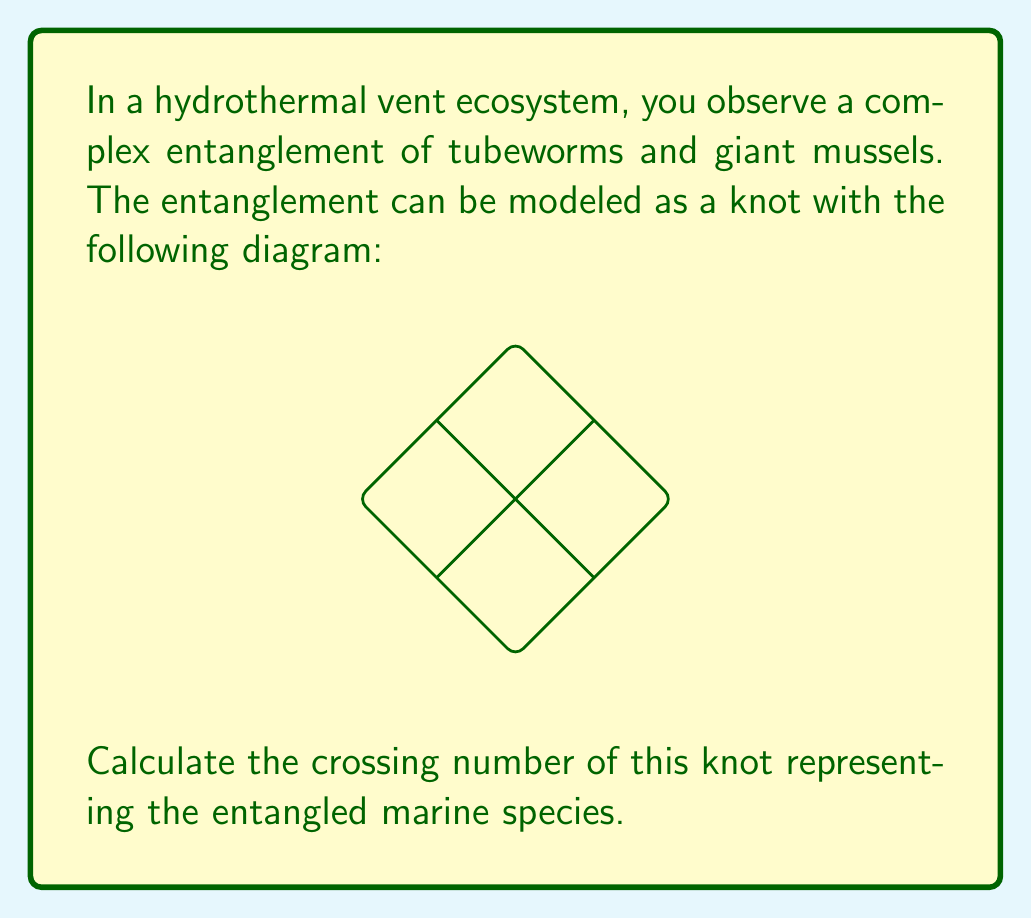What is the answer to this math problem? To determine the crossing number of the knot representing the entangled marine species, we need to follow these steps:

1. Understand the definition: The crossing number of a knot is the minimum number of crossings that occur in any projection of the knot onto a plane.

2. Analyze the given diagram:
   - Count the number of crossings in the provided projection.
   - In this diagram, we can clearly see 4 crossings.

3. Consider if this is the minimal representation:
   - For this particular knot, known as the "figure-eight knot," it is proven that 4 is indeed the minimal number of crossings possible in any projection.
   - No matter how we manipulate or redraw this knot, we cannot reduce the number of crossings below 4 without changing the knot type.

4. Recognize the knot:
   - This knot is formally known as the 4₁ knot in knot theory notation, which confirms that its crossing number is 4.

5. Interpret in context:
   - In our hydrothermal vent ecosystem, this means that the entanglement of tubeworms and giant mussels has a complexity that cannot be reduced below 4 crossings when viewed from any angle.

Therefore, the crossing number of this knot representing the entangled marine species is 4.
Answer: 4 